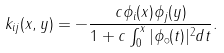<formula> <loc_0><loc_0><loc_500><loc_500>k _ { i j } ( x , y ) = - \frac { c \phi _ { i } ( x ) \phi _ { j } ( y ) } { 1 + c \int _ { 0 } ^ { x } | \phi _ { \circ } ( t ) | ^ { 2 } d t } .</formula> 